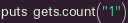<code> <loc_0><loc_0><loc_500><loc_500><_Ruby_>puts gets.count("1")</code> 